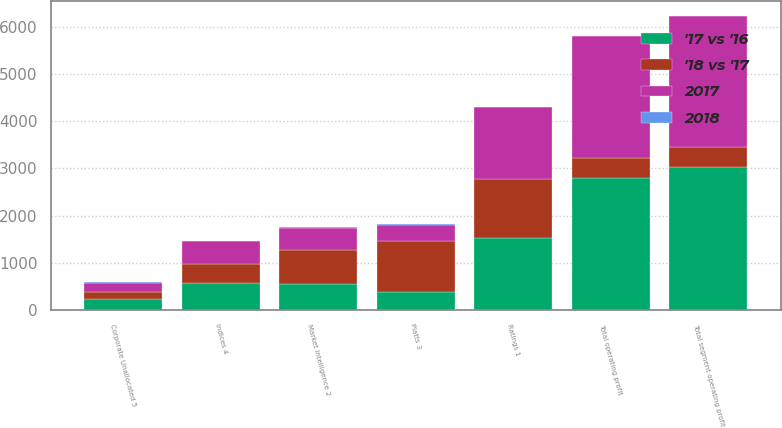<chart> <loc_0><loc_0><loc_500><loc_500><stacked_bar_chart><ecel><fcel>Ratings 1<fcel>Market Intelligence 2<fcel>Platts 3<fcel>Indices 4<fcel>Total segment operating profit<fcel>Corporate Unallocated 5<fcel>Total operating profit<nl><fcel>'17 vs '16<fcel>1530<fcel>545<fcel>383<fcel>563<fcel>3021<fcel>231<fcel>2790<nl><fcel>2017<fcel>1517<fcel>457<fcel>326<fcel>478<fcel>2778<fcel>195<fcel>2583<nl><fcel>'18 vs '17<fcel>1256<fcel>729<fcel>1090<fcel>413<fcel>435<fcel>147<fcel>435<nl><fcel>2018<fcel>1<fcel>19<fcel>18<fcel>18<fcel>9<fcel>19<fcel>8<nl></chart> 